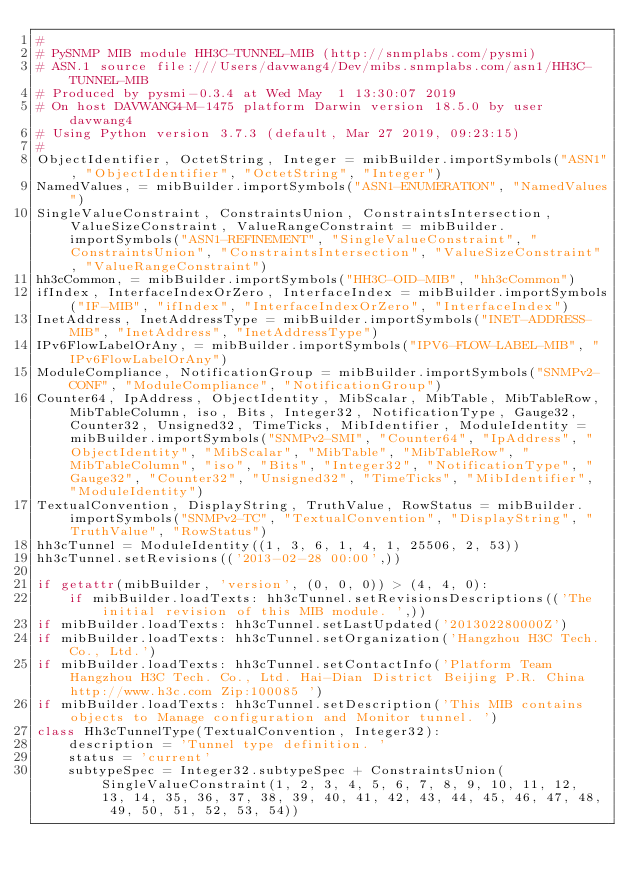Convert code to text. <code><loc_0><loc_0><loc_500><loc_500><_Python_>#
# PySNMP MIB module HH3C-TUNNEL-MIB (http://snmplabs.com/pysmi)
# ASN.1 source file:///Users/davwang4/Dev/mibs.snmplabs.com/asn1/HH3C-TUNNEL-MIB
# Produced by pysmi-0.3.4 at Wed May  1 13:30:07 2019
# On host DAVWANG4-M-1475 platform Darwin version 18.5.0 by user davwang4
# Using Python version 3.7.3 (default, Mar 27 2019, 09:23:15) 
#
ObjectIdentifier, OctetString, Integer = mibBuilder.importSymbols("ASN1", "ObjectIdentifier", "OctetString", "Integer")
NamedValues, = mibBuilder.importSymbols("ASN1-ENUMERATION", "NamedValues")
SingleValueConstraint, ConstraintsUnion, ConstraintsIntersection, ValueSizeConstraint, ValueRangeConstraint = mibBuilder.importSymbols("ASN1-REFINEMENT", "SingleValueConstraint", "ConstraintsUnion", "ConstraintsIntersection", "ValueSizeConstraint", "ValueRangeConstraint")
hh3cCommon, = mibBuilder.importSymbols("HH3C-OID-MIB", "hh3cCommon")
ifIndex, InterfaceIndexOrZero, InterfaceIndex = mibBuilder.importSymbols("IF-MIB", "ifIndex", "InterfaceIndexOrZero", "InterfaceIndex")
InetAddress, InetAddressType = mibBuilder.importSymbols("INET-ADDRESS-MIB", "InetAddress", "InetAddressType")
IPv6FlowLabelOrAny, = mibBuilder.importSymbols("IPV6-FLOW-LABEL-MIB", "IPv6FlowLabelOrAny")
ModuleCompliance, NotificationGroup = mibBuilder.importSymbols("SNMPv2-CONF", "ModuleCompliance", "NotificationGroup")
Counter64, IpAddress, ObjectIdentity, MibScalar, MibTable, MibTableRow, MibTableColumn, iso, Bits, Integer32, NotificationType, Gauge32, Counter32, Unsigned32, TimeTicks, MibIdentifier, ModuleIdentity = mibBuilder.importSymbols("SNMPv2-SMI", "Counter64", "IpAddress", "ObjectIdentity", "MibScalar", "MibTable", "MibTableRow", "MibTableColumn", "iso", "Bits", "Integer32", "NotificationType", "Gauge32", "Counter32", "Unsigned32", "TimeTicks", "MibIdentifier", "ModuleIdentity")
TextualConvention, DisplayString, TruthValue, RowStatus = mibBuilder.importSymbols("SNMPv2-TC", "TextualConvention", "DisplayString", "TruthValue", "RowStatus")
hh3cTunnel = ModuleIdentity((1, 3, 6, 1, 4, 1, 25506, 2, 53))
hh3cTunnel.setRevisions(('2013-02-28 00:00',))

if getattr(mibBuilder, 'version', (0, 0, 0)) > (4, 4, 0):
    if mibBuilder.loadTexts: hh3cTunnel.setRevisionsDescriptions(('The initial revision of this MIB module. ',))
if mibBuilder.loadTexts: hh3cTunnel.setLastUpdated('201302280000Z')
if mibBuilder.loadTexts: hh3cTunnel.setOrganization('Hangzhou H3C Tech. Co., Ltd.')
if mibBuilder.loadTexts: hh3cTunnel.setContactInfo('Platform Team Hangzhou H3C Tech. Co., Ltd. Hai-Dian District Beijing P.R. China http://www.h3c.com Zip:100085 ')
if mibBuilder.loadTexts: hh3cTunnel.setDescription('This MIB contains objects to Manage configuration and Monitor tunnel. ')
class Hh3cTunnelType(TextualConvention, Integer32):
    description = 'Tunnel type definition. '
    status = 'current'
    subtypeSpec = Integer32.subtypeSpec + ConstraintsUnion(SingleValueConstraint(1, 2, 3, 4, 5, 6, 7, 8, 9, 10, 11, 12, 13, 14, 35, 36, 37, 38, 39, 40, 41, 42, 43, 44, 45, 46, 47, 48, 49, 50, 51, 52, 53, 54))</code> 